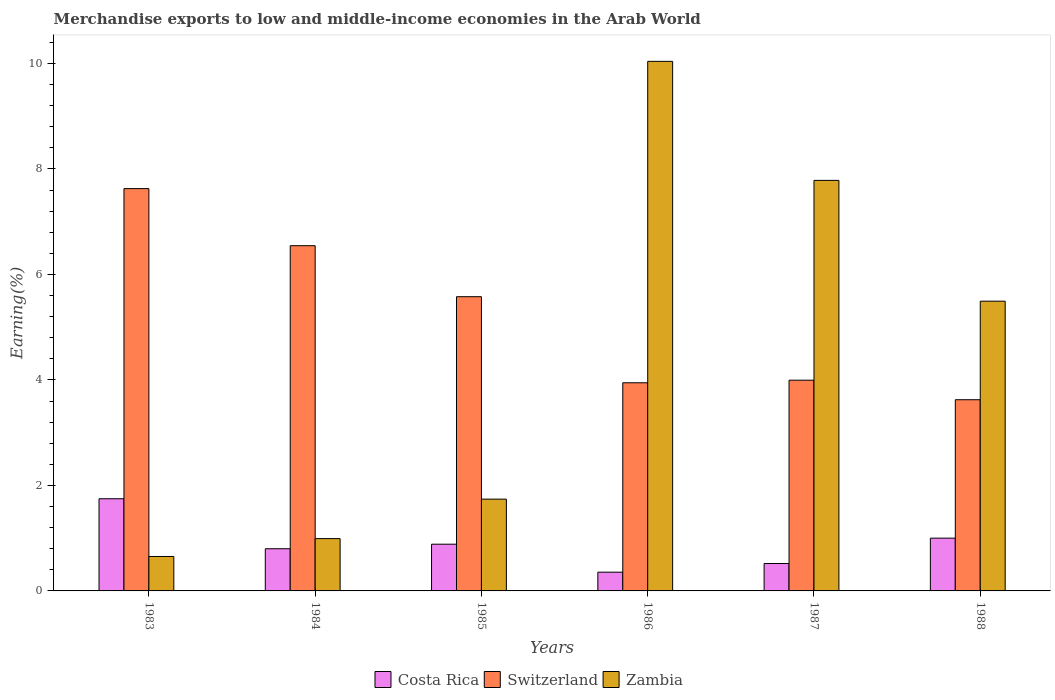How many different coloured bars are there?
Your response must be concise. 3. How many groups of bars are there?
Keep it short and to the point. 6. Are the number of bars per tick equal to the number of legend labels?
Give a very brief answer. Yes. How many bars are there on the 3rd tick from the right?
Make the answer very short. 3. In how many cases, is the number of bars for a given year not equal to the number of legend labels?
Give a very brief answer. 0. What is the percentage of amount earned from merchandise exports in Zambia in 1986?
Give a very brief answer. 10.04. Across all years, what is the maximum percentage of amount earned from merchandise exports in Switzerland?
Your answer should be very brief. 7.63. Across all years, what is the minimum percentage of amount earned from merchandise exports in Switzerland?
Ensure brevity in your answer.  3.62. In which year was the percentage of amount earned from merchandise exports in Zambia maximum?
Keep it short and to the point. 1986. What is the total percentage of amount earned from merchandise exports in Costa Rica in the graph?
Provide a short and direct response. 5.31. What is the difference between the percentage of amount earned from merchandise exports in Costa Rica in 1984 and that in 1985?
Your response must be concise. -0.09. What is the difference between the percentage of amount earned from merchandise exports in Switzerland in 1985 and the percentage of amount earned from merchandise exports in Costa Rica in 1984?
Keep it short and to the point. 4.78. What is the average percentage of amount earned from merchandise exports in Costa Rica per year?
Provide a succinct answer. 0.88. In the year 1988, what is the difference between the percentage of amount earned from merchandise exports in Zambia and percentage of amount earned from merchandise exports in Costa Rica?
Give a very brief answer. 4.49. What is the ratio of the percentage of amount earned from merchandise exports in Switzerland in 1985 to that in 1986?
Keep it short and to the point. 1.41. Is the percentage of amount earned from merchandise exports in Zambia in 1986 less than that in 1987?
Ensure brevity in your answer.  No. Is the difference between the percentage of amount earned from merchandise exports in Zambia in 1986 and 1988 greater than the difference between the percentage of amount earned from merchandise exports in Costa Rica in 1986 and 1988?
Offer a terse response. Yes. What is the difference between the highest and the second highest percentage of amount earned from merchandise exports in Zambia?
Ensure brevity in your answer.  2.26. What is the difference between the highest and the lowest percentage of amount earned from merchandise exports in Costa Rica?
Ensure brevity in your answer.  1.39. In how many years, is the percentage of amount earned from merchandise exports in Zambia greater than the average percentage of amount earned from merchandise exports in Zambia taken over all years?
Offer a very short reply. 3. What does the 3rd bar from the left in 1987 represents?
Provide a succinct answer. Zambia. What does the 1st bar from the right in 1985 represents?
Give a very brief answer. Zambia. Are all the bars in the graph horizontal?
Offer a terse response. No. What is the difference between two consecutive major ticks on the Y-axis?
Your answer should be compact. 2. Are the values on the major ticks of Y-axis written in scientific E-notation?
Your response must be concise. No. Where does the legend appear in the graph?
Provide a short and direct response. Bottom center. What is the title of the graph?
Ensure brevity in your answer.  Merchandise exports to low and middle-income economies in the Arab World. What is the label or title of the X-axis?
Your answer should be compact. Years. What is the label or title of the Y-axis?
Your answer should be very brief. Earning(%). What is the Earning(%) in Costa Rica in 1983?
Your response must be concise. 1.75. What is the Earning(%) in Switzerland in 1983?
Keep it short and to the point. 7.63. What is the Earning(%) in Zambia in 1983?
Provide a succinct answer. 0.65. What is the Earning(%) in Costa Rica in 1984?
Provide a short and direct response. 0.8. What is the Earning(%) in Switzerland in 1984?
Offer a very short reply. 6.54. What is the Earning(%) in Zambia in 1984?
Offer a terse response. 0.99. What is the Earning(%) of Costa Rica in 1985?
Make the answer very short. 0.89. What is the Earning(%) in Switzerland in 1985?
Your answer should be very brief. 5.58. What is the Earning(%) of Zambia in 1985?
Your answer should be very brief. 1.74. What is the Earning(%) of Costa Rica in 1986?
Offer a terse response. 0.36. What is the Earning(%) of Switzerland in 1986?
Provide a short and direct response. 3.95. What is the Earning(%) of Zambia in 1986?
Ensure brevity in your answer.  10.04. What is the Earning(%) in Costa Rica in 1987?
Offer a very short reply. 0.52. What is the Earning(%) in Switzerland in 1987?
Offer a very short reply. 3.99. What is the Earning(%) of Zambia in 1987?
Your answer should be compact. 7.78. What is the Earning(%) of Costa Rica in 1988?
Your answer should be compact. 1. What is the Earning(%) of Switzerland in 1988?
Your answer should be very brief. 3.62. What is the Earning(%) in Zambia in 1988?
Your answer should be compact. 5.49. Across all years, what is the maximum Earning(%) in Costa Rica?
Offer a very short reply. 1.75. Across all years, what is the maximum Earning(%) in Switzerland?
Your response must be concise. 7.63. Across all years, what is the maximum Earning(%) in Zambia?
Provide a short and direct response. 10.04. Across all years, what is the minimum Earning(%) in Costa Rica?
Your answer should be very brief. 0.36. Across all years, what is the minimum Earning(%) of Switzerland?
Ensure brevity in your answer.  3.62. Across all years, what is the minimum Earning(%) in Zambia?
Make the answer very short. 0.65. What is the total Earning(%) in Costa Rica in the graph?
Your answer should be compact. 5.31. What is the total Earning(%) in Switzerland in the graph?
Give a very brief answer. 31.31. What is the total Earning(%) in Zambia in the graph?
Offer a terse response. 26.7. What is the difference between the Earning(%) in Costa Rica in 1983 and that in 1984?
Your response must be concise. 0.95. What is the difference between the Earning(%) of Switzerland in 1983 and that in 1984?
Offer a terse response. 1.08. What is the difference between the Earning(%) in Zambia in 1983 and that in 1984?
Give a very brief answer. -0.34. What is the difference between the Earning(%) of Costa Rica in 1983 and that in 1985?
Offer a terse response. 0.86. What is the difference between the Earning(%) of Switzerland in 1983 and that in 1985?
Provide a succinct answer. 2.05. What is the difference between the Earning(%) of Zambia in 1983 and that in 1985?
Your answer should be very brief. -1.09. What is the difference between the Earning(%) of Costa Rica in 1983 and that in 1986?
Ensure brevity in your answer.  1.39. What is the difference between the Earning(%) in Switzerland in 1983 and that in 1986?
Your answer should be compact. 3.68. What is the difference between the Earning(%) of Zambia in 1983 and that in 1986?
Provide a succinct answer. -9.39. What is the difference between the Earning(%) in Costa Rica in 1983 and that in 1987?
Keep it short and to the point. 1.23. What is the difference between the Earning(%) of Switzerland in 1983 and that in 1987?
Offer a very short reply. 3.63. What is the difference between the Earning(%) of Zambia in 1983 and that in 1987?
Offer a terse response. -7.13. What is the difference between the Earning(%) in Costa Rica in 1983 and that in 1988?
Offer a very short reply. 0.75. What is the difference between the Earning(%) in Switzerland in 1983 and that in 1988?
Provide a short and direct response. 4. What is the difference between the Earning(%) in Zambia in 1983 and that in 1988?
Your answer should be very brief. -4.84. What is the difference between the Earning(%) of Costa Rica in 1984 and that in 1985?
Offer a terse response. -0.09. What is the difference between the Earning(%) of Switzerland in 1984 and that in 1985?
Your answer should be very brief. 0.97. What is the difference between the Earning(%) of Zambia in 1984 and that in 1985?
Your answer should be compact. -0.75. What is the difference between the Earning(%) of Costa Rica in 1984 and that in 1986?
Provide a succinct answer. 0.44. What is the difference between the Earning(%) of Switzerland in 1984 and that in 1986?
Your answer should be very brief. 2.6. What is the difference between the Earning(%) in Zambia in 1984 and that in 1986?
Ensure brevity in your answer.  -9.05. What is the difference between the Earning(%) in Costa Rica in 1984 and that in 1987?
Your answer should be very brief. 0.28. What is the difference between the Earning(%) of Switzerland in 1984 and that in 1987?
Provide a succinct answer. 2.55. What is the difference between the Earning(%) in Zambia in 1984 and that in 1987?
Provide a short and direct response. -6.79. What is the difference between the Earning(%) in Costa Rica in 1984 and that in 1988?
Ensure brevity in your answer.  -0.2. What is the difference between the Earning(%) of Switzerland in 1984 and that in 1988?
Ensure brevity in your answer.  2.92. What is the difference between the Earning(%) in Zambia in 1984 and that in 1988?
Offer a very short reply. -4.5. What is the difference between the Earning(%) of Costa Rica in 1985 and that in 1986?
Offer a terse response. 0.53. What is the difference between the Earning(%) in Switzerland in 1985 and that in 1986?
Offer a terse response. 1.63. What is the difference between the Earning(%) of Zambia in 1985 and that in 1986?
Offer a very short reply. -8.3. What is the difference between the Earning(%) of Costa Rica in 1985 and that in 1987?
Make the answer very short. 0.37. What is the difference between the Earning(%) in Switzerland in 1985 and that in 1987?
Provide a succinct answer. 1.58. What is the difference between the Earning(%) in Zambia in 1985 and that in 1987?
Provide a succinct answer. -6.04. What is the difference between the Earning(%) in Costa Rica in 1985 and that in 1988?
Offer a terse response. -0.11. What is the difference between the Earning(%) in Switzerland in 1985 and that in 1988?
Offer a very short reply. 1.95. What is the difference between the Earning(%) of Zambia in 1985 and that in 1988?
Your answer should be compact. -3.75. What is the difference between the Earning(%) in Costa Rica in 1986 and that in 1987?
Your response must be concise. -0.16. What is the difference between the Earning(%) of Switzerland in 1986 and that in 1987?
Keep it short and to the point. -0.05. What is the difference between the Earning(%) of Zambia in 1986 and that in 1987?
Ensure brevity in your answer.  2.26. What is the difference between the Earning(%) of Costa Rica in 1986 and that in 1988?
Your answer should be very brief. -0.65. What is the difference between the Earning(%) in Switzerland in 1986 and that in 1988?
Offer a terse response. 0.32. What is the difference between the Earning(%) of Zambia in 1986 and that in 1988?
Make the answer very short. 4.55. What is the difference between the Earning(%) in Costa Rica in 1987 and that in 1988?
Give a very brief answer. -0.48. What is the difference between the Earning(%) of Switzerland in 1987 and that in 1988?
Provide a succinct answer. 0.37. What is the difference between the Earning(%) in Zambia in 1987 and that in 1988?
Ensure brevity in your answer.  2.29. What is the difference between the Earning(%) of Costa Rica in 1983 and the Earning(%) of Switzerland in 1984?
Keep it short and to the point. -4.8. What is the difference between the Earning(%) in Costa Rica in 1983 and the Earning(%) in Zambia in 1984?
Provide a short and direct response. 0.76. What is the difference between the Earning(%) in Switzerland in 1983 and the Earning(%) in Zambia in 1984?
Provide a short and direct response. 6.63. What is the difference between the Earning(%) in Costa Rica in 1983 and the Earning(%) in Switzerland in 1985?
Ensure brevity in your answer.  -3.83. What is the difference between the Earning(%) of Costa Rica in 1983 and the Earning(%) of Zambia in 1985?
Your answer should be compact. 0.01. What is the difference between the Earning(%) of Switzerland in 1983 and the Earning(%) of Zambia in 1985?
Your answer should be compact. 5.89. What is the difference between the Earning(%) of Costa Rica in 1983 and the Earning(%) of Switzerland in 1986?
Ensure brevity in your answer.  -2.2. What is the difference between the Earning(%) in Costa Rica in 1983 and the Earning(%) in Zambia in 1986?
Provide a short and direct response. -8.29. What is the difference between the Earning(%) in Switzerland in 1983 and the Earning(%) in Zambia in 1986?
Make the answer very short. -2.41. What is the difference between the Earning(%) in Costa Rica in 1983 and the Earning(%) in Switzerland in 1987?
Offer a very short reply. -2.25. What is the difference between the Earning(%) of Costa Rica in 1983 and the Earning(%) of Zambia in 1987?
Give a very brief answer. -6.04. What is the difference between the Earning(%) of Switzerland in 1983 and the Earning(%) of Zambia in 1987?
Your answer should be very brief. -0.16. What is the difference between the Earning(%) of Costa Rica in 1983 and the Earning(%) of Switzerland in 1988?
Offer a terse response. -1.88. What is the difference between the Earning(%) in Costa Rica in 1983 and the Earning(%) in Zambia in 1988?
Provide a succinct answer. -3.75. What is the difference between the Earning(%) in Switzerland in 1983 and the Earning(%) in Zambia in 1988?
Provide a succinct answer. 2.13. What is the difference between the Earning(%) of Costa Rica in 1984 and the Earning(%) of Switzerland in 1985?
Offer a very short reply. -4.78. What is the difference between the Earning(%) of Costa Rica in 1984 and the Earning(%) of Zambia in 1985?
Offer a terse response. -0.94. What is the difference between the Earning(%) of Switzerland in 1984 and the Earning(%) of Zambia in 1985?
Ensure brevity in your answer.  4.8. What is the difference between the Earning(%) in Costa Rica in 1984 and the Earning(%) in Switzerland in 1986?
Provide a succinct answer. -3.15. What is the difference between the Earning(%) in Costa Rica in 1984 and the Earning(%) in Zambia in 1986?
Keep it short and to the point. -9.24. What is the difference between the Earning(%) of Switzerland in 1984 and the Earning(%) of Zambia in 1986?
Give a very brief answer. -3.49. What is the difference between the Earning(%) in Costa Rica in 1984 and the Earning(%) in Switzerland in 1987?
Make the answer very short. -3.2. What is the difference between the Earning(%) in Costa Rica in 1984 and the Earning(%) in Zambia in 1987?
Provide a succinct answer. -6.98. What is the difference between the Earning(%) in Switzerland in 1984 and the Earning(%) in Zambia in 1987?
Offer a very short reply. -1.24. What is the difference between the Earning(%) in Costa Rica in 1984 and the Earning(%) in Switzerland in 1988?
Make the answer very short. -2.83. What is the difference between the Earning(%) in Costa Rica in 1984 and the Earning(%) in Zambia in 1988?
Your answer should be compact. -4.69. What is the difference between the Earning(%) of Switzerland in 1984 and the Earning(%) of Zambia in 1988?
Ensure brevity in your answer.  1.05. What is the difference between the Earning(%) of Costa Rica in 1985 and the Earning(%) of Switzerland in 1986?
Give a very brief answer. -3.06. What is the difference between the Earning(%) in Costa Rica in 1985 and the Earning(%) in Zambia in 1986?
Offer a terse response. -9.15. What is the difference between the Earning(%) of Switzerland in 1985 and the Earning(%) of Zambia in 1986?
Offer a terse response. -4.46. What is the difference between the Earning(%) in Costa Rica in 1985 and the Earning(%) in Switzerland in 1987?
Keep it short and to the point. -3.11. What is the difference between the Earning(%) of Costa Rica in 1985 and the Earning(%) of Zambia in 1987?
Ensure brevity in your answer.  -6.9. What is the difference between the Earning(%) of Switzerland in 1985 and the Earning(%) of Zambia in 1987?
Make the answer very short. -2.2. What is the difference between the Earning(%) in Costa Rica in 1985 and the Earning(%) in Switzerland in 1988?
Your response must be concise. -2.74. What is the difference between the Earning(%) of Costa Rica in 1985 and the Earning(%) of Zambia in 1988?
Your answer should be very brief. -4.61. What is the difference between the Earning(%) in Switzerland in 1985 and the Earning(%) in Zambia in 1988?
Give a very brief answer. 0.08. What is the difference between the Earning(%) of Costa Rica in 1986 and the Earning(%) of Switzerland in 1987?
Make the answer very short. -3.64. What is the difference between the Earning(%) in Costa Rica in 1986 and the Earning(%) in Zambia in 1987?
Make the answer very short. -7.43. What is the difference between the Earning(%) in Switzerland in 1986 and the Earning(%) in Zambia in 1987?
Your answer should be very brief. -3.84. What is the difference between the Earning(%) of Costa Rica in 1986 and the Earning(%) of Switzerland in 1988?
Provide a succinct answer. -3.27. What is the difference between the Earning(%) in Costa Rica in 1986 and the Earning(%) in Zambia in 1988?
Offer a terse response. -5.14. What is the difference between the Earning(%) of Switzerland in 1986 and the Earning(%) of Zambia in 1988?
Give a very brief answer. -1.55. What is the difference between the Earning(%) of Costa Rica in 1987 and the Earning(%) of Switzerland in 1988?
Make the answer very short. -3.1. What is the difference between the Earning(%) of Costa Rica in 1987 and the Earning(%) of Zambia in 1988?
Keep it short and to the point. -4.97. What is the difference between the Earning(%) of Switzerland in 1987 and the Earning(%) of Zambia in 1988?
Ensure brevity in your answer.  -1.5. What is the average Earning(%) in Costa Rica per year?
Offer a terse response. 0.88. What is the average Earning(%) in Switzerland per year?
Provide a short and direct response. 5.22. What is the average Earning(%) of Zambia per year?
Your response must be concise. 4.45. In the year 1983, what is the difference between the Earning(%) of Costa Rica and Earning(%) of Switzerland?
Give a very brief answer. -5.88. In the year 1983, what is the difference between the Earning(%) in Costa Rica and Earning(%) in Zambia?
Give a very brief answer. 1.09. In the year 1983, what is the difference between the Earning(%) of Switzerland and Earning(%) of Zambia?
Offer a terse response. 6.97. In the year 1984, what is the difference between the Earning(%) in Costa Rica and Earning(%) in Switzerland?
Offer a terse response. -5.75. In the year 1984, what is the difference between the Earning(%) of Costa Rica and Earning(%) of Zambia?
Keep it short and to the point. -0.19. In the year 1984, what is the difference between the Earning(%) in Switzerland and Earning(%) in Zambia?
Offer a very short reply. 5.55. In the year 1985, what is the difference between the Earning(%) of Costa Rica and Earning(%) of Switzerland?
Your response must be concise. -4.69. In the year 1985, what is the difference between the Earning(%) of Costa Rica and Earning(%) of Zambia?
Keep it short and to the point. -0.85. In the year 1985, what is the difference between the Earning(%) of Switzerland and Earning(%) of Zambia?
Offer a terse response. 3.84. In the year 1986, what is the difference between the Earning(%) of Costa Rica and Earning(%) of Switzerland?
Your answer should be very brief. -3.59. In the year 1986, what is the difference between the Earning(%) in Costa Rica and Earning(%) in Zambia?
Keep it short and to the point. -9.68. In the year 1986, what is the difference between the Earning(%) of Switzerland and Earning(%) of Zambia?
Keep it short and to the point. -6.09. In the year 1987, what is the difference between the Earning(%) of Costa Rica and Earning(%) of Switzerland?
Provide a short and direct response. -3.48. In the year 1987, what is the difference between the Earning(%) of Costa Rica and Earning(%) of Zambia?
Your answer should be very brief. -7.26. In the year 1987, what is the difference between the Earning(%) of Switzerland and Earning(%) of Zambia?
Keep it short and to the point. -3.79. In the year 1988, what is the difference between the Earning(%) in Costa Rica and Earning(%) in Switzerland?
Keep it short and to the point. -2.62. In the year 1988, what is the difference between the Earning(%) in Costa Rica and Earning(%) in Zambia?
Ensure brevity in your answer.  -4.49. In the year 1988, what is the difference between the Earning(%) of Switzerland and Earning(%) of Zambia?
Your answer should be very brief. -1.87. What is the ratio of the Earning(%) of Costa Rica in 1983 to that in 1984?
Your response must be concise. 2.19. What is the ratio of the Earning(%) of Switzerland in 1983 to that in 1984?
Ensure brevity in your answer.  1.17. What is the ratio of the Earning(%) in Zambia in 1983 to that in 1984?
Your answer should be very brief. 0.66. What is the ratio of the Earning(%) in Costa Rica in 1983 to that in 1985?
Offer a terse response. 1.97. What is the ratio of the Earning(%) of Switzerland in 1983 to that in 1985?
Offer a terse response. 1.37. What is the ratio of the Earning(%) of Zambia in 1983 to that in 1985?
Keep it short and to the point. 0.38. What is the ratio of the Earning(%) in Costa Rica in 1983 to that in 1986?
Your answer should be very brief. 4.92. What is the ratio of the Earning(%) in Switzerland in 1983 to that in 1986?
Give a very brief answer. 1.93. What is the ratio of the Earning(%) of Zambia in 1983 to that in 1986?
Offer a very short reply. 0.07. What is the ratio of the Earning(%) in Costa Rica in 1983 to that in 1987?
Provide a short and direct response. 3.36. What is the ratio of the Earning(%) in Switzerland in 1983 to that in 1987?
Ensure brevity in your answer.  1.91. What is the ratio of the Earning(%) of Zambia in 1983 to that in 1987?
Offer a very short reply. 0.08. What is the ratio of the Earning(%) of Costa Rica in 1983 to that in 1988?
Offer a terse response. 1.75. What is the ratio of the Earning(%) in Switzerland in 1983 to that in 1988?
Offer a very short reply. 2.1. What is the ratio of the Earning(%) in Zambia in 1983 to that in 1988?
Your response must be concise. 0.12. What is the ratio of the Earning(%) in Costa Rica in 1984 to that in 1985?
Keep it short and to the point. 0.9. What is the ratio of the Earning(%) of Switzerland in 1984 to that in 1985?
Keep it short and to the point. 1.17. What is the ratio of the Earning(%) in Zambia in 1984 to that in 1985?
Give a very brief answer. 0.57. What is the ratio of the Earning(%) of Costa Rica in 1984 to that in 1986?
Offer a terse response. 2.25. What is the ratio of the Earning(%) of Switzerland in 1984 to that in 1986?
Your answer should be very brief. 1.66. What is the ratio of the Earning(%) of Zambia in 1984 to that in 1986?
Your answer should be very brief. 0.1. What is the ratio of the Earning(%) of Costa Rica in 1984 to that in 1987?
Give a very brief answer. 1.54. What is the ratio of the Earning(%) in Switzerland in 1984 to that in 1987?
Your answer should be very brief. 1.64. What is the ratio of the Earning(%) in Zambia in 1984 to that in 1987?
Provide a short and direct response. 0.13. What is the ratio of the Earning(%) in Costa Rica in 1984 to that in 1988?
Provide a short and direct response. 0.8. What is the ratio of the Earning(%) of Switzerland in 1984 to that in 1988?
Your answer should be very brief. 1.81. What is the ratio of the Earning(%) of Zambia in 1984 to that in 1988?
Provide a succinct answer. 0.18. What is the ratio of the Earning(%) of Costa Rica in 1985 to that in 1986?
Ensure brevity in your answer.  2.49. What is the ratio of the Earning(%) of Switzerland in 1985 to that in 1986?
Offer a very short reply. 1.41. What is the ratio of the Earning(%) of Zambia in 1985 to that in 1986?
Keep it short and to the point. 0.17. What is the ratio of the Earning(%) in Costa Rica in 1985 to that in 1987?
Offer a very short reply. 1.7. What is the ratio of the Earning(%) of Switzerland in 1985 to that in 1987?
Provide a succinct answer. 1.4. What is the ratio of the Earning(%) of Zambia in 1985 to that in 1987?
Provide a short and direct response. 0.22. What is the ratio of the Earning(%) of Costa Rica in 1985 to that in 1988?
Offer a terse response. 0.89. What is the ratio of the Earning(%) in Switzerland in 1985 to that in 1988?
Keep it short and to the point. 1.54. What is the ratio of the Earning(%) in Zambia in 1985 to that in 1988?
Provide a short and direct response. 0.32. What is the ratio of the Earning(%) of Costa Rica in 1986 to that in 1987?
Ensure brevity in your answer.  0.68. What is the ratio of the Earning(%) of Zambia in 1986 to that in 1987?
Ensure brevity in your answer.  1.29. What is the ratio of the Earning(%) of Costa Rica in 1986 to that in 1988?
Offer a terse response. 0.36. What is the ratio of the Earning(%) of Switzerland in 1986 to that in 1988?
Provide a succinct answer. 1.09. What is the ratio of the Earning(%) of Zambia in 1986 to that in 1988?
Provide a short and direct response. 1.83. What is the ratio of the Earning(%) of Costa Rica in 1987 to that in 1988?
Offer a very short reply. 0.52. What is the ratio of the Earning(%) of Switzerland in 1987 to that in 1988?
Your answer should be compact. 1.1. What is the ratio of the Earning(%) of Zambia in 1987 to that in 1988?
Offer a very short reply. 1.42. What is the difference between the highest and the second highest Earning(%) in Costa Rica?
Keep it short and to the point. 0.75. What is the difference between the highest and the second highest Earning(%) in Switzerland?
Make the answer very short. 1.08. What is the difference between the highest and the second highest Earning(%) of Zambia?
Make the answer very short. 2.26. What is the difference between the highest and the lowest Earning(%) in Costa Rica?
Ensure brevity in your answer.  1.39. What is the difference between the highest and the lowest Earning(%) in Switzerland?
Ensure brevity in your answer.  4. What is the difference between the highest and the lowest Earning(%) in Zambia?
Offer a very short reply. 9.39. 